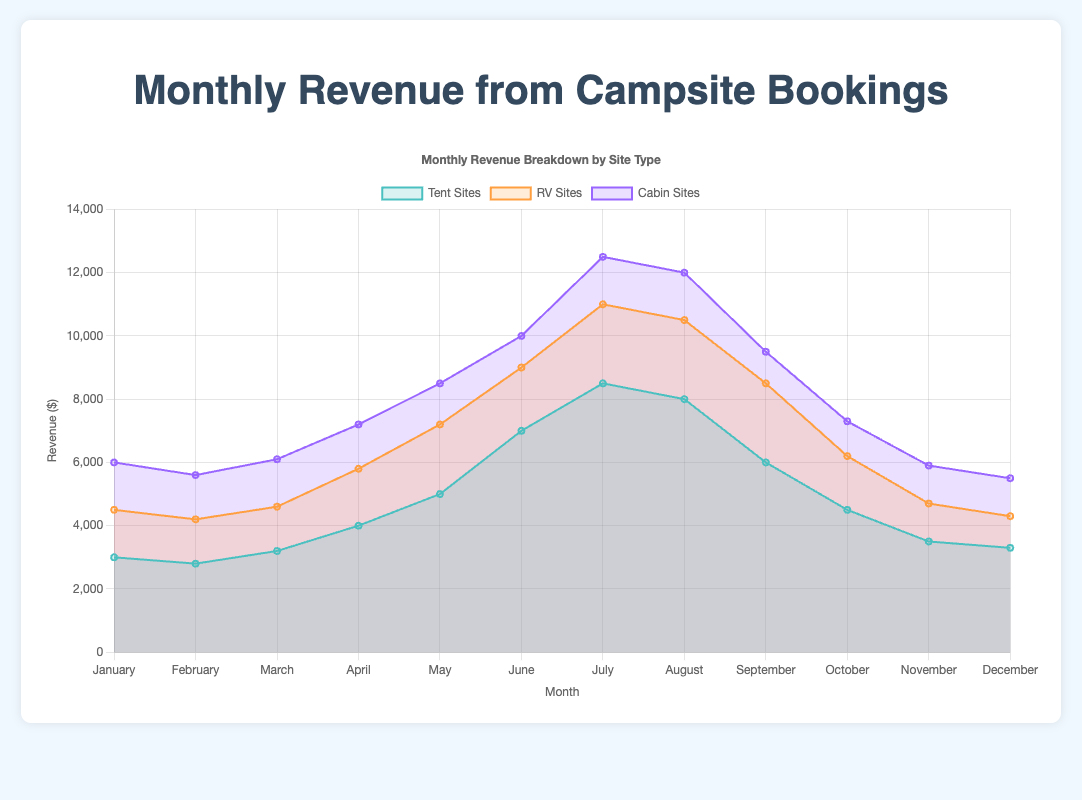What is the highest monthly revenue from tent sites? To determine the highest monthly revenue from tent sites, look at the tent sites' plotted data and identify the peak value. The peak value for tent sites is in July at $8,500.
Answer: $8,500 In which month did RV sites generate the lowest revenue? To find the lowest revenue for RV sites, look for the RV sites' data at the lowest point on the chart. The lowest revenue for RV sites is in February at $4,200.
Answer: February During which month did cabin sites see their maximum revenue? Locate the peak point in the cabin sites' data series on the chart. The highest revenue for cabin sites is in July at $12,500.
Answer: July How does the revenue from tent sites in June compare to that in April? Observe the values for tent sites in June and April. The revenue for tent sites in June is $7,000, compared to $4,000 in April. Thus, June's revenue is higher than April's by $3,000.
Answer: June's revenue is $3,000 higher Which type of site saw the most significant increase in revenue from January to July? Compare the revenue values from January to July for each site type: 
- Tent sites: From $3,000 to $8,500 (increase of $5,500)
- RV sites: From $4,500 to $11,000 (increase of $6,500)
- Cabin sites: From $6,000 to $12,500 (increase of $6,500)
Both RV sites and cabin sites saw a $6,500 increase, which is the highest among the three.
Answer: RV sites and cabin sites What was the total revenue across all site types in May? Sum the revenues of all three site types for May: 
- Tent sites: $5,000
- RV sites: $7,200
- Cabin sites: $8,500
The total revenue is $5,000 + $7,200 + $8,500 = $20,700.
Answer: $20,700 Which month shows the most even distribution of revenue across the three site types? Look for the month where the revenues of tent sites, RV sites, and cabin sites are closest to each other. In July, the revenues are:
- Tent sites: $8,500
- RV sites: $11,000
- Cabin sites: $12,500
The differences between each pair are relatively small compared to other months.
Answer: July How does the revenue trend for tent sites from June to August compare with that for RV sites? Analyze the data points for tent sites and RV sites from June to August:
- Tent sites: $7,000, $8,500, $8,000 (increase, then slight decrease)
- RV sites: $9,000, $11,000, $10,500 (consistent increase, then slight decrease)
Both trends show an increase in July followed by a minor decrease in August.
Answer: Both show increases followed by minor decreases What was the average monthly revenue for cabin sites in the first quarter (January to March)? Average the revenues for cabin sites from January to March: 
- January: $6,000
- February: $5,600
- March: $6,100
The average is ($6,000 + $5,600 + $6,100) / 3 = $5,900.
Answer: $5,900 